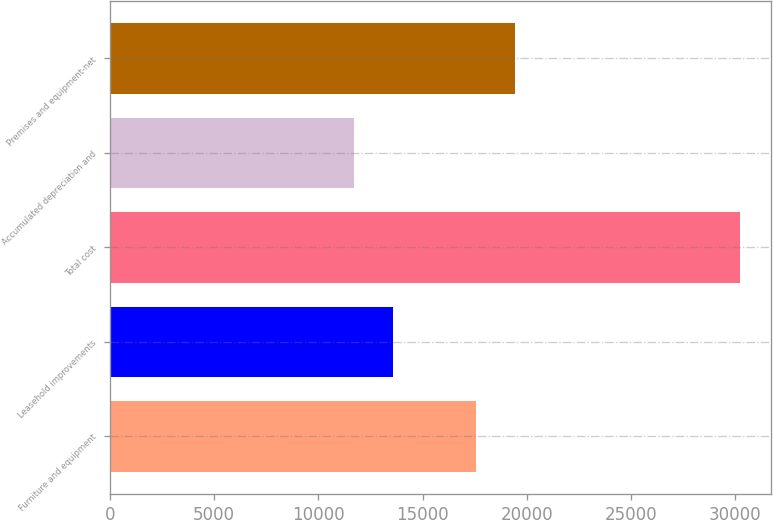Convert chart to OTSL. <chart><loc_0><loc_0><loc_500><loc_500><bar_chart><fcel>Furniture and equipment<fcel>Leasehold improvements<fcel>Total cost<fcel>Accumulated depreciation and<fcel>Premises and equipment-net<nl><fcel>17568<fcel>13572.3<fcel>30216<fcel>11723<fcel>19417.3<nl></chart> 